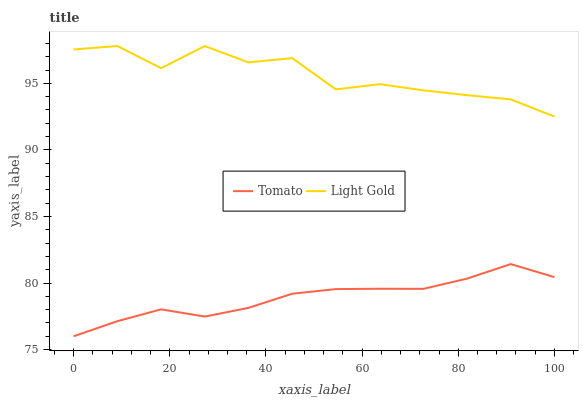Does Tomato have the minimum area under the curve?
Answer yes or no. Yes. Does Light Gold have the maximum area under the curve?
Answer yes or no. Yes. Does Light Gold have the minimum area under the curve?
Answer yes or no. No. Is Tomato the smoothest?
Answer yes or no. Yes. Is Light Gold the roughest?
Answer yes or no. Yes. Is Light Gold the smoothest?
Answer yes or no. No. Does Tomato have the lowest value?
Answer yes or no. Yes. Does Light Gold have the lowest value?
Answer yes or no. No. Does Light Gold have the highest value?
Answer yes or no. Yes. Is Tomato less than Light Gold?
Answer yes or no. Yes. Is Light Gold greater than Tomato?
Answer yes or no. Yes. Does Tomato intersect Light Gold?
Answer yes or no. No. 